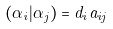<formula> <loc_0><loc_0><loc_500><loc_500>( \alpha _ { i } | \alpha _ { j } ) = d _ { i } a _ { i j }</formula> 